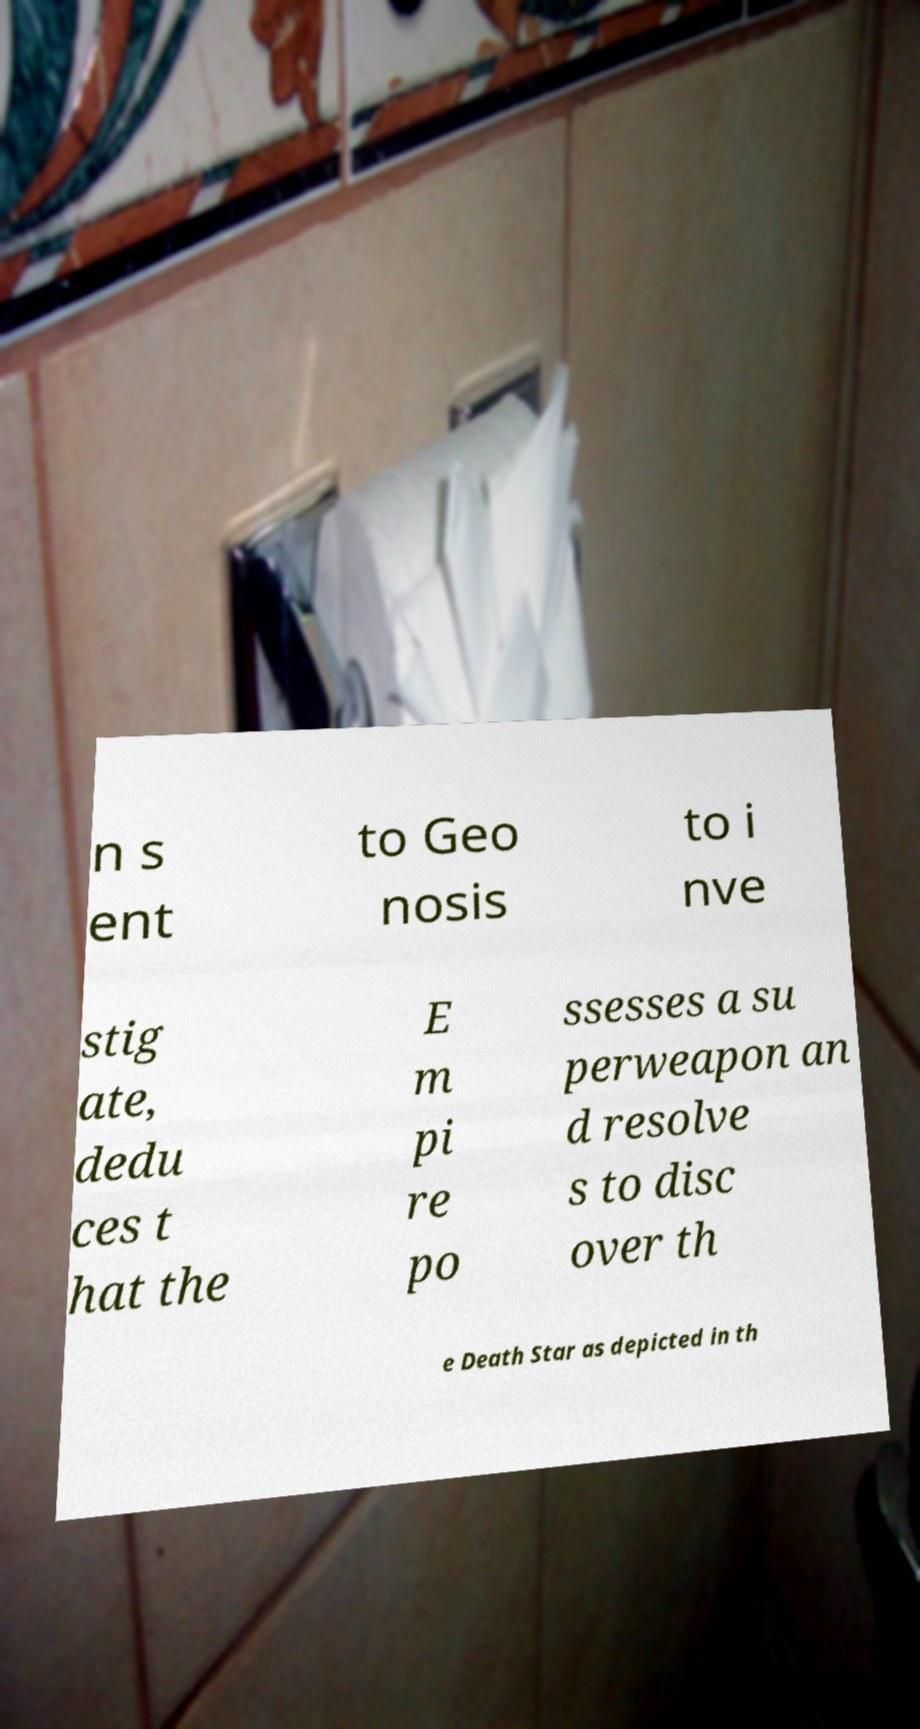Can you accurately transcribe the text from the provided image for me? n s ent to Geo nosis to i nve stig ate, dedu ces t hat the E m pi re po ssesses a su perweapon an d resolve s to disc over th e Death Star as depicted in th 